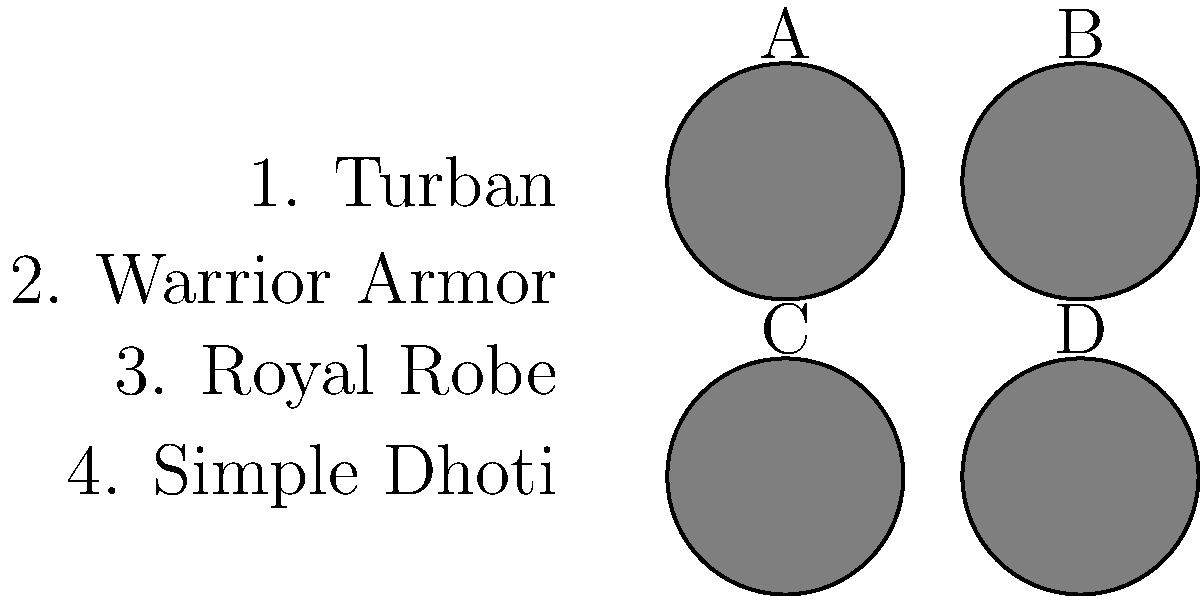Match the silhouettes (A-D) with the corresponding iconic costumes (1-4) worn by Shri Mahadev in his famous movie roles:

1. Turban
2. Warrior Armor
3. Royal Robe
4. Simple Dhoti To match Shri Mahadev's iconic costumes to his movie roles using silhouettes, we need to analyze each silhouette and recall the actor's notable appearances:

1. Silhouette A: This rounded shape suggests a turban, which Shri Mahadev famously wore in his role as a village leader in "Bandhana" (1984).

2. Silhouette B: The broad shoulders and structured outline indicate warrior armor, reminiscent of Shri Mahadev's portrayal of Prabhakara in the historical epic "Mayura" (1975).

3. Silhouette C: The flowing, elegant contours suggest a royal robe, which the actor donned in his role as King Veera Ballala II in "Nagavalli" (1970).

4. Silhouette D: The simple, streamlined shape implies a dhoti, characteristic of Shri Mahadev's portrayal of the common man in "Gejje Pooje" (1969).

By connecting these iconic costumes to Shri Mahadev's memorable roles, we can match each silhouette to the corresponding costume description.
Answer: A-1, B-2, C-3, D-4 